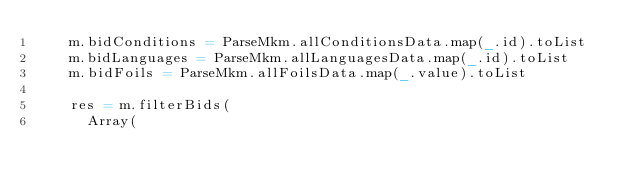Convert code to text. <code><loc_0><loc_0><loc_500><loc_500><_Scala_>    m.bidConditions = ParseMkm.allConditionsData.map(_.id).toList
    m.bidLanguages = ParseMkm.allLanguagesData.map(_.id).toList
    m.bidFoils = ParseMkm.allFoilsData.map(_.value).toList

    res = m.filterBids(
      Array(</code> 